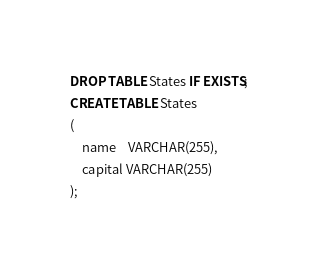Convert code to text. <code><loc_0><loc_0><loc_500><loc_500><_SQL_>DROP TABLE States IF EXISTS;
CREATE TABLE States
(
    name    VARCHAR(255),
    capital VARCHAR(255)
);</code> 